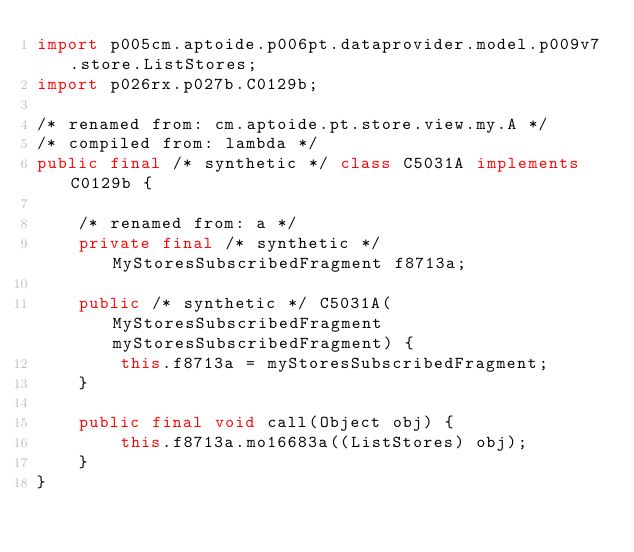<code> <loc_0><loc_0><loc_500><loc_500><_Java_>import p005cm.aptoide.p006pt.dataprovider.model.p009v7.store.ListStores;
import p026rx.p027b.C0129b;

/* renamed from: cm.aptoide.pt.store.view.my.A */
/* compiled from: lambda */
public final /* synthetic */ class C5031A implements C0129b {

    /* renamed from: a */
    private final /* synthetic */ MyStoresSubscribedFragment f8713a;

    public /* synthetic */ C5031A(MyStoresSubscribedFragment myStoresSubscribedFragment) {
        this.f8713a = myStoresSubscribedFragment;
    }

    public final void call(Object obj) {
        this.f8713a.mo16683a((ListStores) obj);
    }
}
</code> 